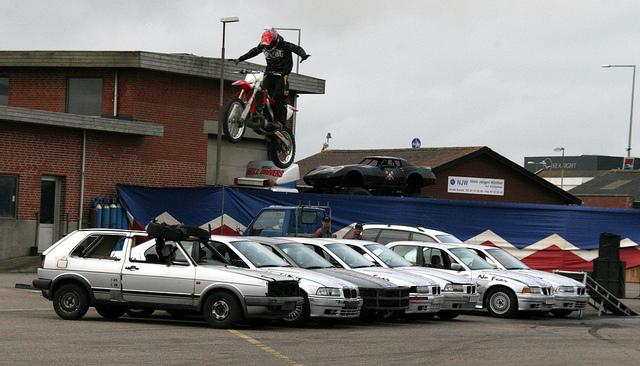Is it at night?
Write a very short answer. No. How many hours can a person park for?
Be succinct. 1. Are the cars parked?
Write a very short answer. Yes. What is the man jumping the cars on?
Give a very brief answer. Motorcycle. What color are the trucks in the foreground?
Write a very short answer. Blue. How many cars are there?
Short answer required. 7. 